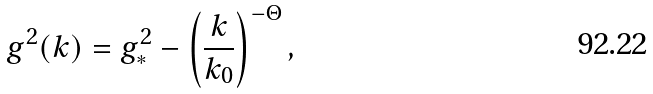Convert formula to latex. <formula><loc_0><loc_0><loc_500><loc_500>g ^ { 2 } ( k ) = g _ { \ast } ^ { 2 } - \left ( \frac { k } { k _ { 0 } } \right ) ^ { - \Theta } ,</formula> 